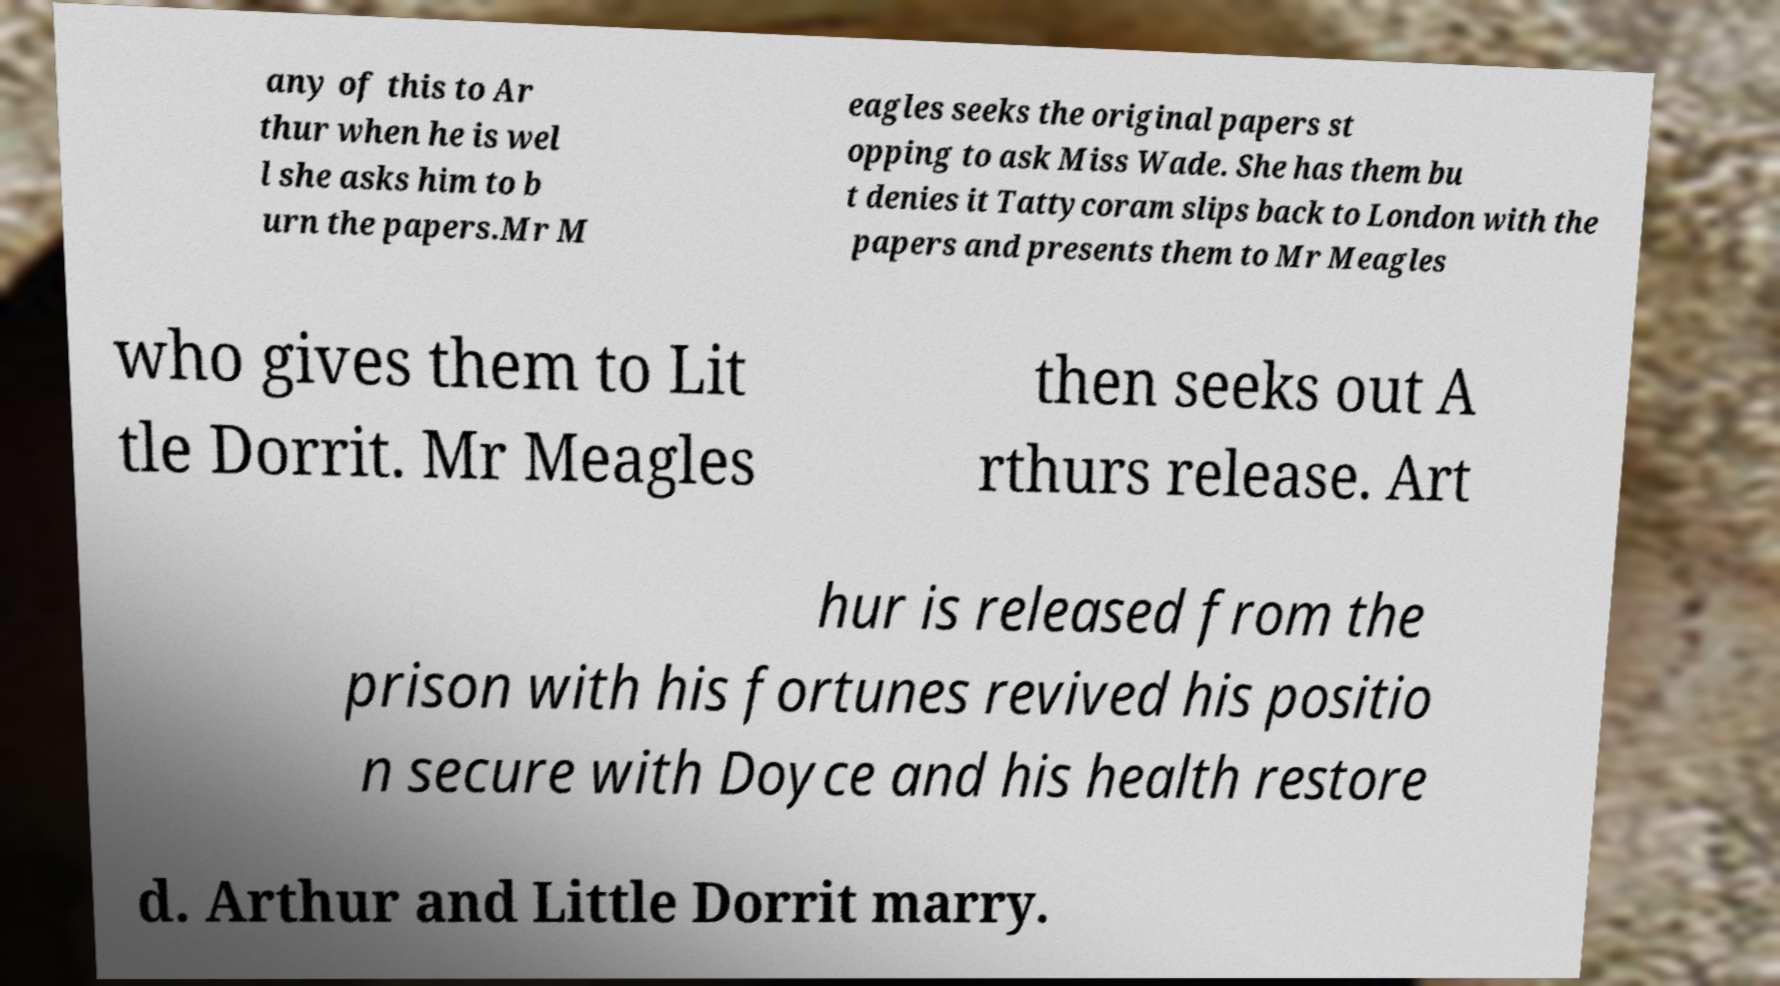Please read and relay the text visible in this image. What does it say? any of this to Ar thur when he is wel l she asks him to b urn the papers.Mr M eagles seeks the original papers st opping to ask Miss Wade. She has them bu t denies it Tattycoram slips back to London with the papers and presents them to Mr Meagles who gives them to Lit tle Dorrit. Mr Meagles then seeks out A rthurs release. Art hur is released from the prison with his fortunes revived his positio n secure with Doyce and his health restore d. Arthur and Little Dorrit marry. 